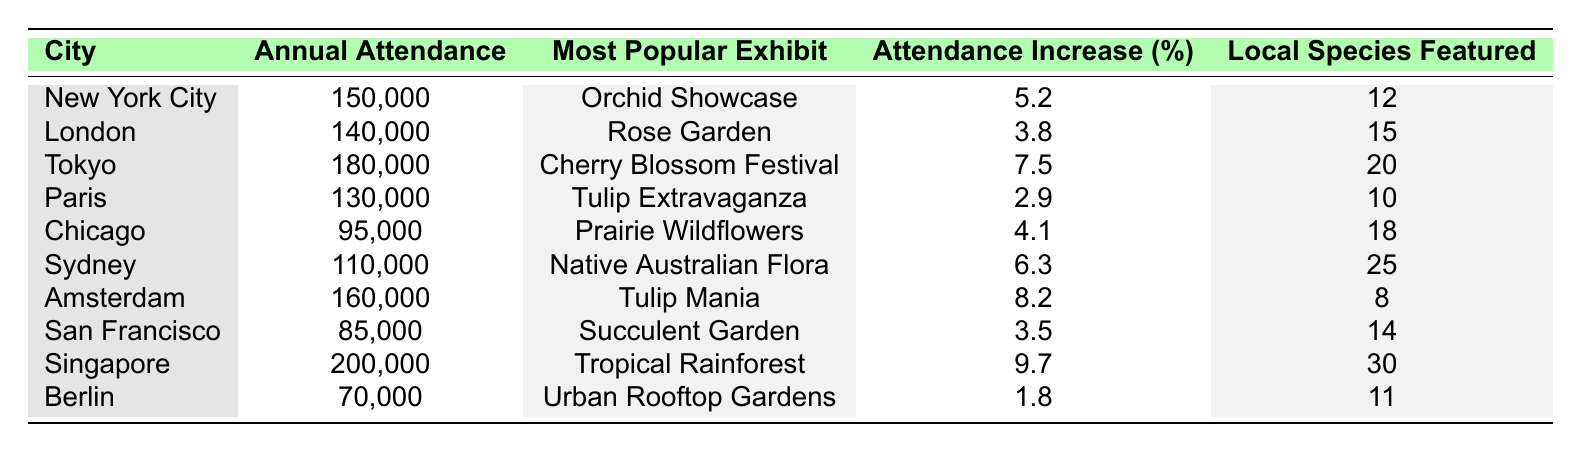What city has the highest annual attendance at the flower show? Looking at the "Annual Attendance" column, Tokyo has the highest number with 180,000 attendees.
Answer: Tokyo Which city featured the "Tulip Extravaganza" as its most popular exhibit? The table lists Paris with "Tulip Extravaganza" as the most popular exhibit under the "Most Popular Exhibit" column.
Answer: Paris What is the attendance increase percentage for Sydney? The "Attendance Increase (%)" column shows that Sydney has an increase of 6.3%.
Answer: 6.3% Which city had the smallest attendance at the flower show? Referring to the "Annual Attendance" column, Berlin has the smallest attendance with 70,000.
Answer: Berlin If we combine the attendance of New York City and London, what is the total? Adding the attendances for New York City (150,000) and London (140,000) gives a total of 290,000 (150,000 + 140,000 = 290,000).
Answer: 290,000 Is the "Cherry Blossom Festival" the most popular exhibit in any city with an attendance of over 150,000? Yes, Tokyo features the "Cherry Blossom Festival" with an attendance of 180,000, which is over 150,000.
Answer: Yes What is the average attendance for the cities that featured local species? The cities featuring local species are New York City, Chicago, Sydney, and Berlin with attendances of 150,000, 95,000, 110,000, and 70,000 respectively. The total attendance for these cities is 150,000 + 95,000 + 110,000 + 70,000 = 425,000. There are 4 cities, so the average is 425,000 / 4 = 106,250.
Answer: 106,250 Which exhibit has the highest attendance increase percentage and what is that percentage? The "Tropical Rainforest" in Singapore has the highest attendance increase at 9.7%.
Answer: 9.7% What is the total local species featured in the top three cities by attendance? The top three cities by attendance are Singapore (30), Tokyo (20), and Amsterdam (8). Adding them gives 30 + 20 + 8 = 58 local species featured.
Answer: 58 Did San Francisco have more local species featured than Paris? San Francisco has 14 local species, while Paris has 10. Hence, San Francisco had more local species featured than Paris.
Answer: Yes What is the difference in attendance between the cities with the highest and lowest attendance? The attendance difference is between Tokyo (180,000) and Berlin (70,000), which is 180,000 - 70,000 = 110,000.
Answer: 110,000 